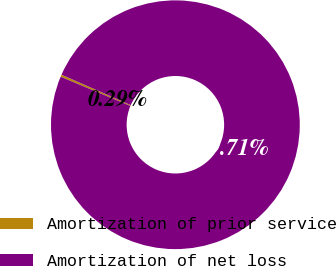<chart> <loc_0><loc_0><loc_500><loc_500><pie_chart><fcel>Amortization of prior service<fcel>Amortization of net loss<nl><fcel>0.29%<fcel>99.71%<nl></chart> 